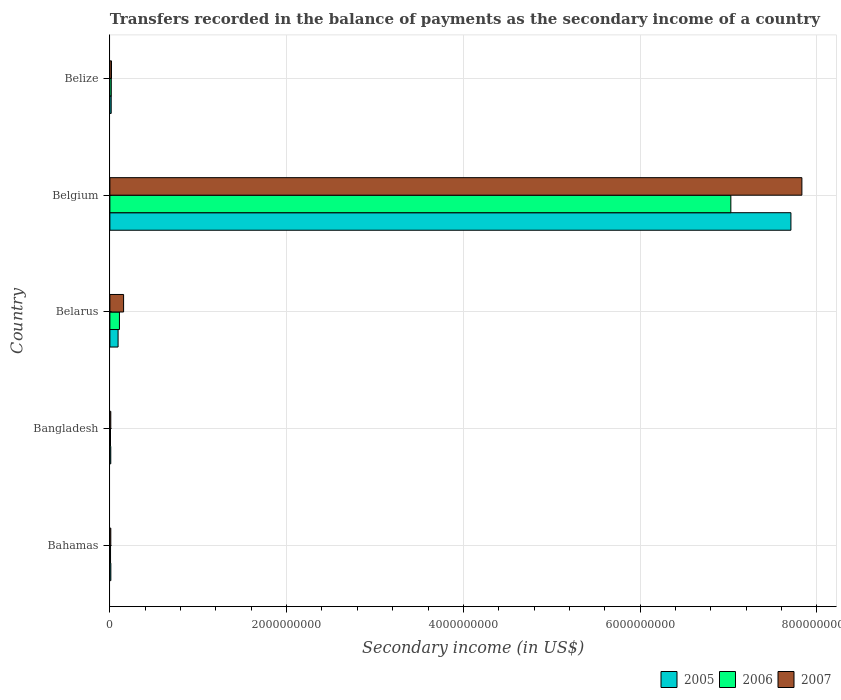How many different coloured bars are there?
Ensure brevity in your answer.  3. Are the number of bars per tick equal to the number of legend labels?
Ensure brevity in your answer.  Yes. How many bars are there on the 1st tick from the bottom?
Give a very brief answer. 3. What is the label of the 3rd group of bars from the top?
Your response must be concise. Belarus. In how many cases, is the number of bars for a given country not equal to the number of legend labels?
Provide a short and direct response. 0. What is the secondary income of in 2006 in Belgium?
Give a very brief answer. 7.03e+09. Across all countries, what is the maximum secondary income of in 2007?
Your answer should be compact. 7.83e+09. Across all countries, what is the minimum secondary income of in 2005?
Make the answer very short. 9.91e+06. In which country was the secondary income of in 2007 maximum?
Make the answer very short. Belgium. What is the total secondary income of in 2005 in the graph?
Make the answer very short. 7.84e+09. What is the difference between the secondary income of in 2007 in Bahamas and that in Belarus?
Make the answer very short. -1.45e+08. What is the difference between the secondary income of in 2007 in Belize and the secondary income of in 2006 in Belarus?
Give a very brief answer. -9.01e+07. What is the average secondary income of in 2007 per country?
Ensure brevity in your answer.  1.60e+09. What is the difference between the secondary income of in 2005 and secondary income of in 2007 in Bahamas?
Make the answer very short. 4.76e+05. In how many countries, is the secondary income of in 2007 greater than 3200000000 US$?
Your answer should be very brief. 1. What is the ratio of the secondary income of in 2006 in Bangladesh to that in Belgium?
Provide a short and direct response. 0. Is the difference between the secondary income of in 2005 in Bahamas and Belgium greater than the difference between the secondary income of in 2007 in Bahamas and Belgium?
Your response must be concise. Yes. What is the difference between the highest and the second highest secondary income of in 2005?
Ensure brevity in your answer.  7.61e+09. What is the difference between the highest and the lowest secondary income of in 2005?
Offer a terse response. 7.70e+09. What does the 3rd bar from the top in Belize represents?
Keep it short and to the point. 2005. What does the 2nd bar from the bottom in Bahamas represents?
Your answer should be very brief. 2006. Is it the case that in every country, the sum of the secondary income of in 2006 and secondary income of in 2007 is greater than the secondary income of in 2005?
Ensure brevity in your answer.  Yes. Does the graph contain any zero values?
Ensure brevity in your answer.  No. Does the graph contain grids?
Offer a terse response. Yes. Where does the legend appear in the graph?
Provide a short and direct response. Bottom right. How are the legend labels stacked?
Your response must be concise. Horizontal. What is the title of the graph?
Provide a succinct answer. Transfers recorded in the balance of payments as the secondary income of a country. What is the label or title of the X-axis?
Ensure brevity in your answer.  Secondary income (in US$). What is the label or title of the Y-axis?
Your answer should be compact. Country. What is the Secondary income (in US$) of 2005 in Bahamas?
Give a very brief answer. 1.08e+07. What is the Secondary income (in US$) of 2006 in Bahamas?
Make the answer very short. 7.49e+06. What is the Secondary income (in US$) in 2007 in Bahamas?
Make the answer very short. 1.03e+07. What is the Secondary income (in US$) in 2005 in Bangladesh?
Provide a succinct answer. 9.91e+06. What is the Secondary income (in US$) in 2006 in Bangladesh?
Your response must be concise. 6.82e+06. What is the Secondary income (in US$) in 2007 in Bangladesh?
Your response must be concise. 1.01e+07. What is the Secondary income (in US$) of 2005 in Belarus?
Keep it short and to the point. 9.27e+07. What is the Secondary income (in US$) in 2006 in Belarus?
Make the answer very short. 1.08e+08. What is the Secondary income (in US$) in 2007 in Belarus?
Give a very brief answer. 1.55e+08. What is the Secondary income (in US$) in 2005 in Belgium?
Your answer should be very brief. 7.71e+09. What is the Secondary income (in US$) in 2006 in Belgium?
Your response must be concise. 7.03e+09. What is the Secondary income (in US$) of 2007 in Belgium?
Keep it short and to the point. 7.83e+09. What is the Secondary income (in US$) of 2005 in Belize?
Provide a succinct answer. 1.48e+07. What is the Secondary income (in US$) in 2006 in Belize?
Your response must be concise. 1.58e+07. What is the Secondary income (in US$) in 2007 in Belize?
Your answer should be very brief. 1.80e+07. Across all countries, what is the maximum Secondary income (in US$) in 2005?
Your answer should be compact. 7.71e+09. Across all countries, what is the maximum Secondary income (in US$) of 2006?
Make the answer very short. 7.03e+09. Across all countries, what is the maximum Secondary income (in US$) in 2007?
Offer a terse response. 7.83e+09. Across all countries, what is the minimum Secondary income (in US$) of 2005?
Make the answer very short. 9.91e+06. Across all countries, what is the minimum Secondary income (in US$) in 2006?
Provide a succinct answer. 6.82e+06. Across all countries, what is the minimum Secondary income (in US$) of 2007?
Offer a terse response. 1.01e+07. What is the total Secondary income (in US$) in 2005 in the graph?
Keep it short and to the point. 7.84e+09. What is the total Secondary income (in US$) in 2006 in the graph?
Offer a terse response. 7.17e+09. What is the total Secondary income (in US$) in 2007 in the graph?
Offer a terse response. 8.02e+09. What is the difference between the Secondary income (in US$) in 2005 in Bahamas and that in Bangladesh?
Provide a succinct answer. 8.77e+05. What is the difference between the Secondary income (in US$) in 2006 in Bahamas and that in Bangladesh?
Provide a short and direct response. 6.74e+05. What is the difference between the Secondary income (in US$) in 2007 in Bahamas and that in Bangladesh?
Your response must be concise. 2.30e+05. What is the difference between the Secondary income (in US$) in 2005 in Bahamas and that in Belarus?
Keep it short and to the point. -8.19e+07. What is the difference between the Secondary income (in US$) in 2006 in Bahamas and that in Belarus?
Keep it short and to the point. -1.01e+08. What is the difference between the Secondary income (in US$) in 2007 in Bahamas and that in Belarus?
Provide a short and direct response. -1.45e+08. What is the difference between the Secondary income (in US$) of 2005 in Bahamas and that in Belgium?
Keep it short and to the point. -7.70e+09. What is the difference between the Secondary income (in US$) of 2006 in Bahamas and that in Belgium?
Offer a terse response. -7.02e+09. What is the difference between the Secondary income (in US$) in 2007 in Bahamas and that in Belgium?
Provide a short and direct response. -7.82e+09. What is the difference between the Secondary income (in US$) of 2005 in Bahamas and that in Belize?
Offer a terse response. -3.98e+06. What is the difference between the Secondary income (in US$) in 2006 in Bahamas and that in Belize?
Give a very brief answer. -8.26e+06. What is the difference between the Secondary income (in US$) of 2007 in Bahamas and that in Belize?
Give a very brief answer. -7.69e+06. What is the difference between the Secondary income (in US$) in 2005 in Bangladesh and that in Belarus?
Ensure brevity in your answer.  -8.28e+07. What is the difference between the Secondary income (in US$) in 2006 in Bangladesh and that in Belarus?
Give a very brief answer. -1.01e+08. What is the difference between the Secondary income (in US$) in 2007 in Bangladesh and that in Belarus?
Your response must be concise. -1.45e+08. What is the difference between the Secondary income (in US$) in 2005 in Bangladesh and that in Belgium?
Give a very brief answer. -7.70e+09. What is the difference between the Secondary income (in US$) of 2006 in Bangladesh and that in Belgium?
Your answer should be compact. -7.02e+09. What is the difference between the Secondary income (in US$) of 2007 in Bangladesh and that in Belgium?
Make the answer very short. -7.82e+09. What is the difference between the Secondary income (in US$) of 2005 in Bangladesh and that in Belize?
Give a very brief answer. -4.86e+06. What is the difference between the Secondary income (in US$) of 2006 in Bangladesh and that in Belize?
Ensure brevity in your answer.  -8.94e+06. What is the difference between the Secondary income (in US$) in 2007 in Bangladesh and that in Belize?
Keep it short and to the point. -7.92e+06. What is the difference between the Secondary income (in US$) in 2005 in Belarus and that in Belgium?
Offer a terse response. -7.61e+09. What is the difference between the Secondary income (in US$) in 2006 in Belarus and that in Belgium?
Provide a succinct answer. -6.92e+09. What is the difference between the Secondary income (in US$) in 2007 in Belarus and that in Belgium?
Offer a very short reply. -7.68e+09. What is the difference between the Secondary income (in US$) in 2005 in Belarus and that in Belize?
Give a very brief answer. 7.79e+07. What is the difference between the Secondary income (in US$) of 2006 in Belarus and that in Belize?
Give a very brief answer. 9.23e+07. What is the difference between the Secondary income (in US$) in 2007 in Belarus and that in Belize?
Keep it short and to the point. 1.37e+08. What is the difference between the Secondary income (in US$) in 2005 in Belgium and that in Belize?
Provide a short and direct response. 7.69e+09. What is the difference between the Secondary income (in US$) of 2006 in Belgium and that in Belize?
Your answer should be compact. 7.01e+09. What is the difference between the Secondary income (in US$) of 2007 in Belgium and that in Belize?
Provide a succinct answer. 7.81e+09. What is the difference between the Secondary income (in US$) of 2005 in Bahamas and the Secondary income (in US$) of 2006 in Bangladesh?
Provide a succinct answer. 3.97e+06. What is the difference between the Secondary income (in US$) of 2005 in Bahamas and the Secondary income (in US$) of 2007 in Bangladesh?
Offer a terse response. 7.06e+05. What is the difference between the Secondary income (in US$) in 2006 in Bahamas and the Secondary income (in US$) in 2007 in Bangladesh?
Provide a succinct answer. -2.59e+06. What is the difference between the Secondary income (in US$) in 2005 in Bahamas and the Secondary income (in US$) in 2006 in Belarus?
Offer a terse response. -9.73e+07. What is the difference between the Secondary income (in US$) of 2005 in Bahamas and the Secondary income (in US$) of 2007 in Belarus?
Ensure brevity in your answer.  -1.44e+08. What is the difference between the Secondary income (in US$) in 2006 in Bahamas and the Secondary income (in US$) in 2007 in Belarus?
Your answer should be compact. -1.48e+08. What is the difference between the Secondary income (in US$) in 2005 in Bahamas and the Secondary income (in US$) in 2006 in Belgium?
Ensure brevity in your answer.  -7.02e+09. What is the difference between the Secondary income (in US$) of 2005 in Bahamas and the Secondary income (in US$) of 2007 in Belgium?
Ensure brevity in your answer.  -7.82e+09. What is the difference between the Secondary income (in US$) in 2006 in Bahamas and the Secondary income (in US$) in 2007 in Belgium?
Your answer should be very brief. -7.82e+09. What is the difference between the Secondary income (in US$) of 2005 in Bahamas and the Secondary income (in US$) of 2006 in Belize?
Ensure brevity in your answer.  -4.96e+06. What is the difference between the Secondary income (in US$) of 2005 in Bahamas and the Secondary income (in US$) of 2007 in Belize?
Give a very brief answer. -7.21e+06. What is the difference between the Secondary income (in US$) in 2006 in Bahamas and the Secondary income (in US$) in 2007 in Belize?
Give a very brief answer. -1.05e+07. What is the difference between the Secondary income (in US$) in 2005 in Bangladesh and the Secondary income (in US$) in 2006 in Belarus?
Offer a very short reply. -9.82e+07. What is the difference between the Secondary income (in US$) of 2005 in Bangladesh and the Secondary income (in US$) of 2007 in Belarus?
Provide a short and direct response. -1.45e+08. What is the difference between the Secondary income (in US$) in 2006 in Bangladesh and the Secondary income (in US$) in 2007 in Belarus?
Provide a succinct answer. -1.48e+08. What is the difference between the Secondary income (in US$) of 2005 in Bangladesh and the Secondary income (in US$) of 2006 in Belgium?
Make the answer very short. -7.02e+09. What is the difference between the Secondary income (in US$) in 2005 in Bangladesh and the Secondary income (in US$) in 2007 in Belgium?
Ensure brevity in your answer.  -7.82e+09. What is the difference between the Secondary income (in US$) of 2006 in Bangladesh and the Secondary income (in US$) of 2007 in Belgium?
Offer a very short reply. -7.82e+09. What is the difference between the Secondary income (in US$) in 2005 in Bangladesh and the Secondary income (in US$) in 2006 in Belize?
Ensure brevity in your answer.  -5.84e+06. What is the difference between the Secondary income (in US$) in 2005 in Bangladesh and the Secondary income (in US$) in 2007 in Belize?
Your answer should be compact. -8.09e+06. What is the difference between the Secondary income (in US$) in 2006 in Bangladesh and the Secondary income (in US$) in 2007 in Belize?
Give a very brief answer. -1.12e+07. What is the difference between the Secondary income (in US$) of 2005 in Belarus and the Secondary income (in US$) of 2006 in Belgium?
Ensure brevity in your answer.  -6.93e+09. What is the difference between the Secondary income (in US$) of 2005 in Belarus and the Secondary income (in US$) of 2007 in Belgium?
Make the answer very short. -7.74e+09. What is the difference between the Secondary income (in US$) in 2006 in Belarus and the Secondary income (in US$) in 2007 in Belgium?
Give a very brief answer. -7.72e+09. What is the difference between the Secondary income (in US$) of 2005 in Belarus and the Secondary income (in US$) of 2006 in Belize?
Your response must be concise. 7.69e+07. What is the difference between the Secondary income (in US$) in 2005 in Belarus and the Secondary income (in US$) in 2007 in Belize?
Offer a very short reply. 7.47e+07. What is the difference between the Secondary income (in US$) in 2006 in Belarus and the Secondary income (in US$) in 2007 in Belize?
Offer a very short reply. 9.01e+07. What is the difference between the Secondary income (in US$) of 2005 in Belgium and the Secondary income (in US$) of 2006 in Belize?
Ensure brevity in your answer.  7.69e+09. What is the difference between the Secondary income (in US$) in 2005 in Belgium and the Secondary income (in US$) in 2007 in Belize?
Keep it short and to the point. 7.69e+09. What is the difference between the Secondary income (in US$) of 2006 in Belgium and the Secondary income (in US$) of 2007 in Belize?
Provide a short and direct response. 7.01e+09. What is the average Secondary income (in US$) in 2005 per country?
Offer a very short reply. 1.57e+09. What is the average Secondary income (in US$) in 2006 per country?
Provide a succinct answer. 1.43e+09. What is the average Secondary income (in US$) in 2007 per country?
Offer a terse response. 1.60e+09. What is the difference between the Secondary income (in US$) in 2005 and Secondary income (in US$) in 2006 in Bahamas?
Your answer should be very brief. 3.30e+06. What is the difference between the Secondary income (in US$) of 2005 and Secondary income (in US$) of 2007 in Bahamas?
Ensure brevity in your answer.  4.76e+05. What is the difference between the Secondary income (in US$) of 2006 and Secondary income (in US$) of 2007 in Bahamas?
Your response must be concise. -2.82e+06. What is the difference between the Secondary income (in US$) of 2005 and Secondary income (in US$) of 2006 in Bangladesh?
Your answer should be very brief. 3.09e+06. What is the difference between the Secondary income (in US$) of 2005 and Secondary income (in US$) of 2007 in Bangladesh?
Ensure brevity in your answer.  -1.71e+05. What is the difference between the Secondary income (in US$) in 2006 and Secondary income (in US$) in 2007 in Bangladesh?
Your response must be concise. -3.26e+06. What is the difference between the Secondary income (in US$) of 2005 and Secondary income (in US$) of 2006 in Belarus?
Ensure brevity in your answer.  -1.54e+07. What is the difference between the Secondary income (in US$) of 2005 and Secondary income (in US$) of 2007 in Belarus?
Your answer should be compact. -6.23e+07. What is the difference between the Secondary income (in US$) in 2006 and Secondary income (in US$) in 2007 in Belarus?
Your answer should be very brief. -4.69e+07. What is the difference between the Secondary income (in US$) in 2005 and Secondary income (in US$) in 2006 in Belgium?
Provide a succinct answer. 6.80e+08. What is the difference between the Secondary income (in US$) of 2005 and Secondary income (in US$) of 2007 in Belgium?
Give a very brief answer. -1.24e+08. What is the difference between the Secondary income (in US$) of 2006 and Secondary income (in US$) of 2007 in Belgium?
Offer a terse response. -8.04e+08. What is the difference between the Secondary income (in US$) in 2005 and Secondary income (in US$) in 2006 in Belize?
Keep it short and to the point. -9.82e+05. What is the difference between the Secondary income (in US$) in 2005 and Secondary income (in US$) in 2007 in Belize?
Keep it short and to the point. -3.23e+06. What is the difference between the Secondary income (in US$) in 2006 and Secondary income (in US$) in 2007 in Belize?
Provide a succinct answer. -2.25e+06. What is the ratio of the Secondary income (in US$) of 2005 in Bahamas to that in Bangladesh?
Provide a succinct answer. 1.09. What is the ratio of the Secondary income (in US$) of 2006 in Bahamas to that in Bangladesh?
Make the answer very short. 1.1. What is the ratio of the Secondary income (in US$) of 2007 in Bahamas to that in Bangladesh?
Ensure brevity in your answer.  1.02. What is the ratio of the Secondary income (in US$) of 2005 in Bahamas to that in Belarus?
Ensure brevity in your answer.  0.12. What is the ratio of the Secondary income (in US$) of 2006 in Bahamas to that in Belarus?
Keep it short and to the point. 0.07. What is the ratio of the Secondary income (in US$) of 2007 in Bahamas to that in Belarus?
Provide a succinct answer. 0.07. What is the ratio of the Secondary income (in US$) of 2005 in Bahamas to that in Belgium?
Provide a short and direct response. 0. What is the ratio of the Secondary income (in US$) in 2006 in Bahamas to that in Belgium?
Your answer should be very brief. 0. What is the ratio of the Secondary income (in US$) of 2007 in Bahamas to that in Belgium?
Make the answer very short. 0. What is the ratio of the Secondary income (in US$) in 2005 in Bahamas to that in Belize?
Your response must be concise. 0.73. What is the ratio of the Secondary income (in US$) in 2006 in Bahamas to that in Belize?
Keep it short and to the point. 0.48. What is the ratio of the Secondary income (in US$) of 2007 in Bahamas to that in Belize?
Make the answer very short. 0.57. What is the ratio of the Secondary income (in US$) of 2005 in Bangladesh to that in Belarus?
Keep it short and to the point. 0.11. What is the ratio of the Secondary income (in US$) in 2006 in Bangladesh to that in Belarus?
Provide a short and direct response. 0.06. What is the ratio of the Secondary income (in US$) in 2007 in Bangladesh to that in Belarus?
Ensure brevity in your answer.  0.07. What is the ratio of the Secondary income (in US$) of 2005 in Bangladesh to that in Belgium?
Provide a short and direct response. 0. What is the ratio of the Secondary income (in US$) in 2007 in Bangladesh to that in Belgium?
Offer a terse response. 0. What is the ratio of the Secondary income (in US$) in 2005 in Bangladesh to that in Belize?
Your response must be concise. 0.67. What is the ratio of the Secondary income (in US$) of 2006 in Bangladesh to that in Belize?
Offer a terse response. 0.43. What is the ratio of the Secondary income (in US$) of 2007 in Bangladesh to that in Belize?
Offer a very short reply. 0.56. What is the ratio of the Secondary income (in US$) in 2005 in Belarus to that in Belgium?
Your answer should be very brief. 0.01. What is the ratio of the Secondary income (in US$) of 2006 in Belarus to that in Belgium?
Provide a short and direct response. 0.02. What is the ratio of the Secondary income (in US$) of 2007 in Belarus to that in Belgium?
Give a very brief answer. 0.02. What is the ratio of the Secondary income (in US$) of 2005 in Belarus to that in Belize?
Your response must be concise. 6.28. What is the ratio of the Secondary income (in US$) in 2006 in Belarus to that in Belize?
Offer a very short reply. 6.86. What is the ratio of the Secondary income (in US$) in 2007 in Belarus to that in Belize?
Provide a succinct answer. 8.61. What is the ratio of the Secondary income (in US$) of 2005 in Belgium to that in Belize?
Your answer should be compact. 521.84. What is the ratio of the Secondary income (in US$) in 2006 in Belgium to that in Belize?
Provide a short and direct response. 446.15. What is the ratio of the Secondary income (in US$) of 2007 in Belgium to that in Belize?
Make the answer very short. 435.15. What is the difference between the highest and the second highest Secondary income (in US$) in 2005?
Give a very brief answer. 7.61e+09. What is the difference between the highest and the second highest Secondary income (in US$) of 2006?
Offer a very short reply. 6.92e+09. What is the difference between the highest and the second highest Secondary income (in US$) of 2007?
Your answer should be compact. 7.68e+09. What is the difference between the highest and the lowest Secondary income (in US$) in 2005?
Offer a terse response. 7.70e+09. What is the difference between the highest and the lowest Secondary income (in US$) of 2006?
Give a very brief answer. 7.02e+09. What is the difference between the highest and the lowest Secondary income (in US$) in 2007?
Offer a very short reply. 7.82e+09. 